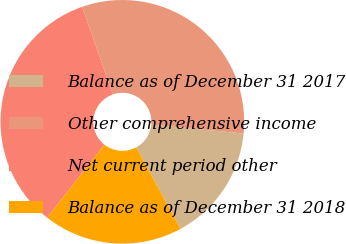Convert chart. <chart><loc_0><loc_0><loc_500><loc_500><pie_chart><fcel>Balance as of December 31 2017<fcel>Other comprehensive income<fcel>Net current period other<fcel>Balance as of December 31 2018<nl><fcel>15.53%<fcel>31.88%<fcel>34.06%<fcel>18.53%<nl></chart> 